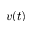Convert formula to latex. <formula><loc_0><loc_0><loc_500><loc_500>v ( t )</formula> 